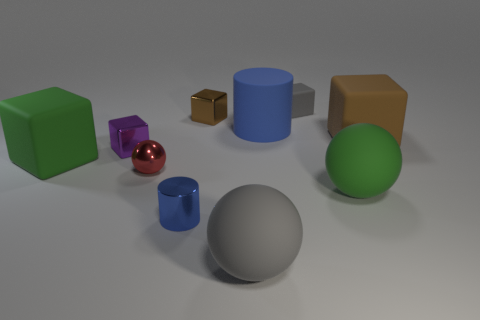Subtract all green blocks. How many blocks are left? 4 Subtract all green rubber blocks. How many blocks are left? 4 Subtract all yellow blocks. Subtract all cyan balls. How many blocks are left? 5 Subtract all spheres. How many objects are left? 7 Subtract 0 yellow spheres. How many objects are left? 10 Subtract all metallic balls. Subtract all tiny brown metal things. How many objects are left? 8 Add 1 blue cylinders. How many blue cylinders are left? 3 Add 6 gray matte things. How many gray matte things exist? 8 